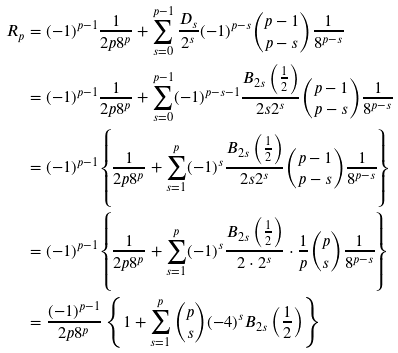Convert formula to latex. <formula><loc_0><loc_0><loc_500><loc_500>R _ { p } & = ( - 1 ) ^ { p - 1 } \frac { 1 } { 2 p 8 ^ { p } } + \sum _ { s = 0 } ^ { p - 1 } \frac { D _ { s } } { 2 ^ { s } } ( - 1 ) ^ { p - s } \binom { p - 1 } { p - s } \frac { 1 } { 8 ^ { p - s } } \\ & = ( - 1 ) ^ { p - 1 } \frac { 1 } { 2 p 8 ^ { p } } + \sum _ { s = 0 } ^ { p - 1 } ( - 1 ) ^ { p - s - 1 } \frac { B _ { 2 s } \left ( \frac { 1 } { 2 } \right ) } { 2 s 2 ^ { s } } \binom { p - 1 } { p - s } \frac { 1 } { 8 ^ { p - s } } \\ & = ( - 1 ) ^ { p - 1 } \left \{ \frac { 1 } { 2 p 8 ^ { p } } + \sum _ { s = 1 } ^ { p } ( - 1 ) ^ { s } \frac { B _ { 2 s } \left ( \frac { 1 } { 2 } \right ) } { 2 s 2 ^ { s } } \binom { p - 1 } { p - s } \frac { 1 } { 8 ^ { p - s } } \right \} \\ & = ( - 1 ) ^ { p - 1 } \left \{ \frac { 1 } { 2 p 8 ^ { p } } + \sum _ { s = 1 } ^ { p } ( - 1 ) ^ { s } \frac { B _ { 2 s } \left ( \frac { 1 } { 2 } \right ) } { 2 \cdot 2 ^ { s } } \cdot \frac { 1 } { p } \binom { p } { s } \frac { 1 } { 8 ^ { p - s } } \right \} \\ & = \frac { ( - 1 ) ^ { p - 1 } } { 2 p 8 ^ { p } } \left \{ 1 + \sum _ { s = 1 } ^ { p } \binom { p } { s } ( - 4 ) ^ { s } B _ { 2 s } \left ( \frac { 1 } { 2 } \right ) \right \} \\</formula> 